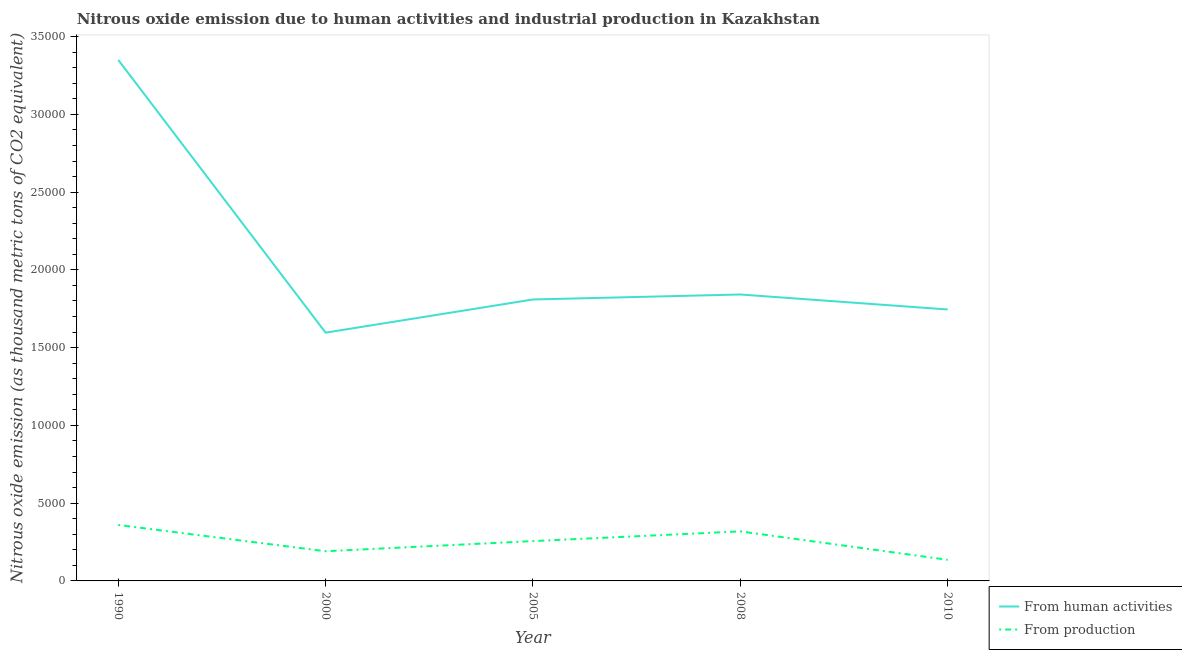Is the number of lines equal to the number of legend labels?
Provide a short and direct response. Yes. What is the amount of emissions from human activities in 2005?
Keep it short and to the point. 1.81e+04. Across all years, what is the maximum amount of emissions generated from industries?
Offer a very short reply. 3597.7. Across all years, what is the minimum amount of emissions from human activities?
Give a very brief answer. 1.60e+04. In which year was the amount of emissions generated from industries maximum?
Your response must be concise. 1990. What is the total amount of emissions from human activities in the graph?
Offer a terse response. 1.03e+05. What is the difference between the amount of emissions generated from industries in 1990 and that in 2008?
Keep it short and to the point. 412.1. What is the difference between the amount of emissions from human activities in 2010 and the amount of emissions generated from industries in 1990?
Make the answer very short. 1.39e+04. What is the average amount of emissions from human activities per year?
Offer a very short reply. 2.07e+04. In the year 2000, what is the difference between the amount of emissions generated from industries and amount of emissions from human activities?
Your answer should be compact. -1.41e+04. What is the ratio of the amount of emissions from human activities in 2005 to that in 2010?
Provide a short and direct response. 1.04. Is the difference between the amount of emissions from human activities in 2005 and 2008 greater than the difference between the amount of emissions generated from industries in 2005 and 2008?
Provide a succinct answer. Yes. What is the difference between the highest and the second highest amount of emissions from human activities?
Offer a terse response. 1.51e+04. What is the difference between the highest and the lowest amount of emissions from human activities?
Your answer should be very brief. 1.75e+04. In how many years, is the amount of emissions generated from industries greater than the average amount of emissions generated from industries taken over all years?
Give a very brief answer. 3. Does the amount of emissions from human activities monotonically increase over the years?
Provide a short and direct response. No. Is the amount of emissions generated from industries strictly greater than the amount of emissions from human activities over the years?
Give a very brief answer. No. Is the amount of emissions from human activities strictly less than the amount of emissions generated from industries over the years?
Your answer should be very brief. No. How many years are there in the graph?
Make the answer very short. 5. What is the difference between two consecutive major ticks on the Y-axis?
Offer a very short reply. 5000. Does the graph contain any zero values?
Make the answer very short. No. Does the graph contain grids?
Keep it short and to the point. No. How are the legend labels stacked?
Your answer should be very brief. Vertical. What is the title of the graph?
Make the answer very short. Nitrous oxide emission due to human activities and industrial production in Kazakhstan. Does "Urban" appear as one of the legend labels in the graph?
Give a very brief answer. No. What is the label or title of the X-axis?
Make the answer very short. Year. What is the label or title of the Y-axis?
Ensure brevity in your answer.  Nitrous oxide emission (as thousand metric tons of CO2 equivalent). What is the Nitrous oxide emission (as thousand metric tons of CO2 equivalent) of From human activities in 1990?
Your answer should be compact. 3.35e+04. What is the Nitrous oxide emission (as thousand metric tons of CO2 equivalent) of From production in 1990?
Offer a very short reply. 3597.7. What is the Nitrous oxide emission (as thousand metric tons of CO2 equivalent) of From human activities in 2000?
Offer a very short reply. 1.60e+04. What is the Nitrous oxide emission (as thousand metric tons of CO2 equivalent) in From production in 2000?
Provide a short and direct response. 1908.3. What is the Nitrous oxide emission (as thousand metric tons of CO2 equivalent) of From human activities in 2005?
Make the answer very short. 1.81e+04. What is the Nitrous oxide emission (as thousand metric tons of CO2 equivalent) of From production in 2005?
Keep it short and to the point. 2561.2. What is the Nitrous oxide emission (as thousand metric tons of CO2 equivalent) in From human activities in 2008?
Offer a very short reply. 1.84e+04. What is the Nitrous oxide emission (as thousand metric tons of CO2 equivalent) of From production in 2008?
Keep it short and to the point. 3185.6. What is the Nitrous oxide emission (as thousand metric tons of CO2 equivalent) in From human activities in 2010?
Keep it short and to the point. 1.75e+04. What is the Nitrous oxide emission (as thousand metric tons of CO2 equivalent) of From production in 2010?
Ensure brevity in your answer.  1356.9. Across all years, what is the maximum Nitrous oxide emission (as thousand metric tons of CO2 equivalent) of From human activities?
Provide a succinct answer. 3.35e+04. Across all years, what is the maximum Nitrous oxide emission (as thousand metric tons of CO2 equivalent) in From production?
Keep it short and to the point. 3597.7. Across all years, what is the minimum Nitrous oxide emission (as thousand metric tons of CO2 equivalent) of From human activities?
Provide a short and direct response. 1.60e+04. Across all years, what is the minimum Nitrous oxide emission (as thousand metric tons of CO2 equivalent) in From production?
Provide a short and direct response. 1356.9. What is the total Nitrous oxide emission (as thousand metric tons of CO2 equivalent) of From human activities in the graph?
Offer a very short reply. 1.03e+05. What is the total Nitrous oxide emission (as thousand metric tons of CO2 equivalent) in From production in the graph?
Provide a short and direct response. 1.26e+04. What is the difference between the Nitrous oxide emission (as thousand metric tons of CO2 equivalent) of From human activities in 1990 and that in 2000?
Your answer should be very brief. 1.75e+04. What is the difference between the Nitrous oxide emission (as thousand metric tons of CO2 equivalent) of From production in 1990 and that in 2000?
Provide a succinct answer. 1689.4. What is the difference between the Nitrous oxide emission (as thousand metric tons of CO2 equivalent) in From human activities in 1990 and that in 2005?
Your response must be concise. 1.54e+04. What is the difference between the Nitrous oxide emission (as thousand metric tons of CO2 equivalent) of From production in 1990 and that in 2005?
Provide a short and direct response. 1036.5. What is the difference between the Nitrous oxide emission (as thousand metric tons of CO2 equivalent) in From human activities in 1990 and that in 2008?
Offer a very short reply. 1.51e+04. What is the difference between the Nitrous oxide emission (as thousand metric tons of CO2 equivalent) in From production in 1990 and that in 2008?
Keep it short and to the point. 412.1. What is the difference between the Nitrous oxide emission (as thousand metric tons of CO2 equivalent) of From human activities in 1990 and that in 2010?
Offer a very short reply. 1.61e+04. What is the difference between the Nitrous oxide emission (as thousand metric tons of CO2 equivalent) in From production in 1990 and that in 2010?
Give a very brief answer. 2240.8. What is the difference between the Nitrous oxide emission (as thousand metric tons of CO2 equivalent) in From human activities in 2000 and that in 2005?
Ensure brevity in your answer.  -2133.3. What is the difference between the Nitrous oxide emission (as thousand metric tons of CO2 equivalent) of From production in 2000 and that in 2005?
Provide a short and direct response. -652.9. What is the difference between the Nitrous oxide emission (as thousand metric tons of CO2 equivalent) of From human activities in 2000 and that in 2008?
Provide a short and direct response. -2454. What is the difference between the Nitrous oxide emission (as thousand metric tons of CO2 equivalent) of From production in 2000 and that in 2008?
Offer a very short reply. -1277.3. What is the difference between the Nitrous oxide emission (as thousand metric tons of CO2 equivalent) of From human activities in 2000 and that in 2010?
Your answer should be very brief. -1489.6. What is the difference between the Nitrous oxide emission (as thousand metric tons of CO2 equivalent) of From production in 2000 and that in 2010?
Your response must be concise. 551.4. What is the difference between the Nitrous oxide emission (as thousand metric tons of CO2 equivalent) in From human activities in 2005 and that in 2008?
Offer a terse response. -320.7. What is the difference between the Nitrous oxide emission (as thousand metric tons of CO2 equivalent) of From production in 2005 and that in 2008?
Make the answer very short. -624.4. What is the difference between the Nitrous oxide emission (as thousand metric tons of CO2 equivalent) in From human activities in 2005 and that in 2010?
Your response must be concise. 643.7. What is the difference between the Nitrous oxide emission (as thousand metric tons of CO2 equivalent) in From production in 2005 and that in 2010?
Provide a short and direct response. 1204.3. What is the difference between the Nitrous oxide emission (as thousand metric tons of CO2 equivalent) in From human activities in 2008 and that in 2010?
Your response must be concise. 964.4. What is the difference between the Nitrous oxide emission (as thousand metric tons of CO2 equivalent) in From production in 2008 and that in 2010?
Offer a terse response. 1828.7. What is the difference between the Nitrous oxide emission (as thousand metric tons of CO2 equivalent) in From human activities in 1990 and the Nitrous oxide emission (as thousand metric tons of CO2 equivalent) in From production in 2000?
Provide a succinct answer. 3.16e+04. What is the difference between the Nitrous oxide emission (as thousand metric tons of CO2 equivalent) of From human activities in 1990 and the Nitrous oxide emission (as thousand metric tons of CO2 equivalent) of From production in 2005?
Make the answer very short. 3.09e+04. What is the difference between the Nitrous oxide emission (as thousand metric tons of CO2 equivalent) in From human activities in 1990 and the Nitrous oxide emission (as thousand metric tons of CO2 equivalent) in From production in 2008?
Provide a succinct answer. 3.03e+04. What is the difference between the Nitrous oxide emission (as thousand metric tons of CO2 equivalent) in From human activities in 1990 and the Nitrous oxide emission (as thousand metric tons of CO2 equivalent) in From production in 2010?
Provide a short and direct response. 3.21e+04. What is the difference between the Nitrous oxide emission (as thousand metric tons of CO2 equivalent) in From human activities in 2000 and the Nitrous oxide emission (as thousand metric tons of CO2 equivalent) in From production in 2005?
Give a very brief answer. 1.34e+04. What is the difference between the Nitrous oxide emission (as thousand metric tons of CO2 equivalent) of From human activities in 2000 and the Nitrous oxide emission (as thousand metric tons of CO2 equivalent) of From production in 2008?
Provide a short and direct response. 1.28e+04. What is the difference between the Nitrous oxide emission (as thousand metric tons of CO2 equivalent) of From human activities in 2000 and the Nitrous oxide emission (as thousand metric tons of CO2 equivalent) of From production in 2010?
Provide a short and direct response. 1.46e+04. What is the difference between the Nitrous oxide emission (as thousand metric tons of CO2 equivalent) in From human activities in 2005 and the Nitrous oxide emission (as thousand metric tons of CO2 equivalent) in From production in 2008?
Your answer should be very brief. 1.49e+04. What is the difference between the Nitrous oxide emission (as thousand metric tons of CO2 equivalent) in From human activities in 2005 and the Nitrous oxide emission (as thousand metric tons of CO2 equivalent) in From production in 2010?
Provide a succinct answer. 1.67e+04. What is the difference between the Nitrous oxide emission (as thousand metric tons of CO2 equivalent) of From human activities in 2008 and the Nitrous oxide emission (as thousand metric tons of CO2 equivalent) of From production in 2010?
Give a very brief answer. 1.71e+04. What is the average Nitrous oxide emission (as thousand metric tons of CO2 equivalent) in From human activities per year?
Keep it short and to the point. 2.07e+04. What is the average Nitrous oxide emission (as thousand metric tons of CO2 equivalent) of From production per year?
Make the answer very short. 2521.94. In the year 1990, what is the difference between the Nitrous oxide emission (as thousand metric tons of CO2 equivalent) in From human activities and Nitrous oxide emission (as thousand metric tons of CO2 equivalent) in From production?
Keep it short and to the point. 2.99e+04. In the year 2000, what is the difference between the Nitrous oxide emission (as thousand metric tons of CO2 equivalent) in From human activities and Nitrous oxide emission (as thousand metric tons of CO2 equivalent) in From production?
Offer a very short reply. 1.41e+04. In the year 2005, what is the difference between the Nitrous oxide emission (as thousand metric tons of CO2 equivalent) in From human activities and Nitrous oxide emission (as thousand metric tons of CO2 equivalent) in From production?
Your response must be concise. 1.55e+04. In the year 2008, what is the difference between the Nitrous oxide emission (as thousand metric tons of CO2 equivalent) of From human activities and Nitrous oxide emission (as thousand metric tons of CO2 equivalent) of From production?
Your answer should be compact. 1.52e+04. In the year 2010, what is the difference between the Nitrous oxide emission (as thousand metric tons of CO2 equivalent) in From human activities and Nitrous oxide emission (as thousand metric tons of CO2 equivalent) in From production?
Keep it short and to the point. 1.61e+04. What is the ratio of the Nitrous oxide emission (as thousand metric tons of CO2 equivalent) of From human activities in 1990 to that in 2000?
Make the answer very short. 2.1. What is the ratio of the Nitrous oxide emission (as thousand metric tons of CO2 equivalent) of From production in 1990 to that in 2000?
Offer a terse response. 1.89. What is the ratio of the Nitrous oxide emission (as thousand metric tons of CO2 equivalent) of From human activities in 1990 to that in 2005?
Your response must be concise. 1.85. What is the ratio of the Nitrous oxide emission (as thousand metric tons of CO2 equivalent) of From production in 1990 to that in 2005?
Keep it short and to the point. 1.4. What is the ratio of the Nitrous oxide emission (as thousand metric tons of CO2 equivalent) in From human activities in 1990 to that in 2008?
Make the answer very short. 1.82. What is the ratio of the Nitrous oxide emission (as thousand metric tons of CO2 equivalent) of From production in 1990 to that in 2008?
Offer a very short reply. 1.13. What is the ratio of the Nitrous oxide emission (as thousand metric tons of CO2 equivalent) in From human activities in 1990 to that in 2010?
Keep it short and to the point. 1.92. What is the ratio of the Nitrous oxide emission (as thousand metric tons of CO2 equivalent) in From production in 1990 to that in 2010?
Make the answer very short. 2.65. What is the ratio of the Nitrous oxide emission (as thousand metric tons of CO2 equivalent) of From human activities in 2000 to that in 2005?
Provide a succinct answer. 0.88. What is the ratio of the Nitrous oxide emission (as thousand metric tons of CO2 equivalent) of From production in 2000 to that in 2005?
Give a very brief answer. 0.75. What is the ratio of the Nitrous oxide emission (as thousand metric tons of CO2 equivalent) of From human activities in 2000 to that in 2008?
Offer a terse response. 0.87. What is the ratio of the Nitrous oxide emission (as thousand metric tons of CO2 equivalent) of From production in 2000 to that in 2008?
Make the answer very short. 0.6. What is the ratio of the Nitrous oxide emission (as thousand metric tons of CO2 equivalent) of From human activities in 2000 to that in 2010?
Provide a succinct answer. 0.91. What is the ratio of the Nitrous oxide emission (as thousand metric tons of CO2 equivalent) of From production in 2000 to that in 2010?
Ensure brevity in your answer.  1.41. What is the ratio of the Nitrous oxide emission (as thousand metric tons of CO2 equivalent) in From human activities in 2005 to that in 2008?
Your response must be concise. 0.98. What is the ratio of the Nitrous oxide emission (as thousand metric tons of CO2 equivalent) of From production in 2005 to that in 2008?
Ensure brevity in your answer.  0.8. What is the ratio of the Nitrous oxide emission (as thousand metric tons of CO2 equivalent) of From human activities in 2005 to that in 2010?
Your answer should be very brief. 1.04. What is the ratio of the Nitrous oxide emission (as thousand metric tons of CO2 equivalent) in From production in 2005 to that in 2010?
Keep it short and to the point. 1.89. What is the ratio of the Nitrous oxide emission (as thousand metric tons of CO2 equivalent) of From human activities in 2008 to that in 2010?
Your response must be concise. 1.06. What is the ratio of the Nitrous oxide emission (as thousand metric tons of CO2 equivalent) in From production in 2008 to that in 2010?
Offer a terse response. 2.35. What is the difference between the highest and the second highest Nitrous oxide emission (as thousand metric tons of CO2 equivalent) of From human activities?
Offer a terse response. 1.51e+04. What is the difference between the highest and the second highest Nitrous oxide emission (as thousand metric tons of CO2 equivalent) in From production?
Offer a very short reply. 412.1. What is the difference between the highest and the lowest Nitrous oxide emission (as thousand metric tons of CO2 equivalent) of From human activities?
Provide a succinct answer. 1.75e+04. What is the difference between the highest and the lowest Nitrous oxide emission (as thousand metric tons of CO2 equivalent) in From production?
Your answer should be compact. 2240.8. 